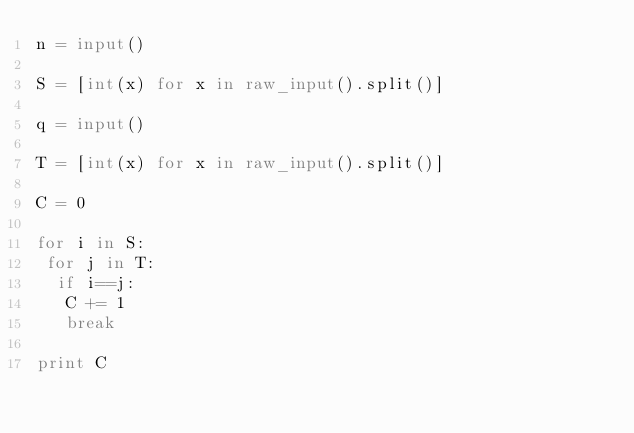Convert code to text. <code><loc_0><loc_0><loc_500><loc_500><_Python_>n = input()

S = [int(x) for x in raw_input().split()]

q = input()

T = [int(x) for x in raw_input().split()]

C = 0

for i in S:
 for j in T:
  if i==j:
   C += 1
   break

print C</code> 